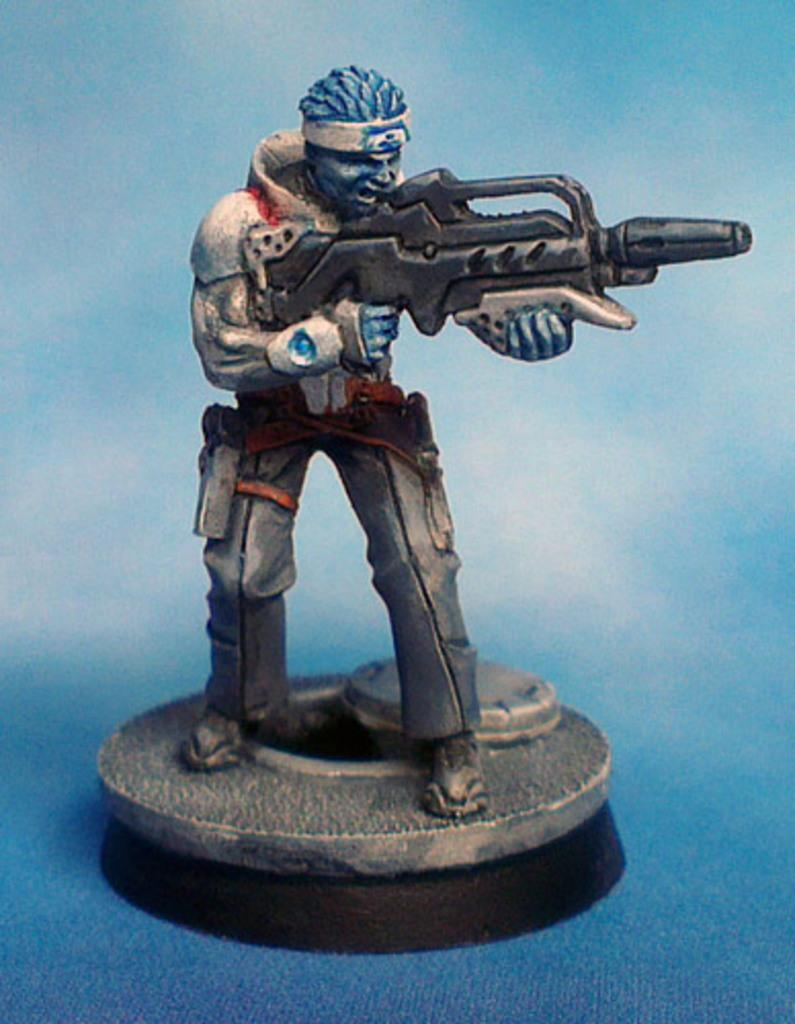What type of toy is present in the image? There is a toy of a man in the image. What is the toy man holding? The toy man is holding a gun. How is the toy man holding the gun? The toy man is holding the gun with his hands. What is the toy man standing on? The toy man is standing on a platform. Can you read the letter that the toy man is holding in the image? There is no letter present in the image; the toy man is holding a gun. 